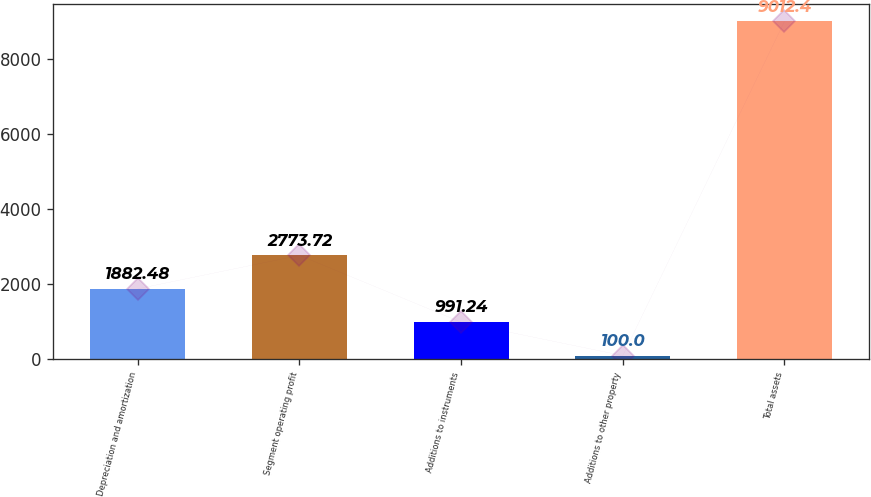Convert chart. <chart><loc_0><loc_0><loc_500><loc_500><bar_chart><fcel>Depreciation and amortization<fcel>Segment operating profit<fcel>Additions to instruments<fcel>Additions to other property<fcel>Total assets<nl><fcel>1882.48<fcel>2773.72<fcel>991.24<fcel>100<fcel>9012.4<nl></chart> 